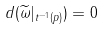<formula> <loc_0><loc_0><loc_500><loc_500>d ( \widetilde { \omega } | _ { t ^ { - 1 } ( p ) } ) = 0</formula> 